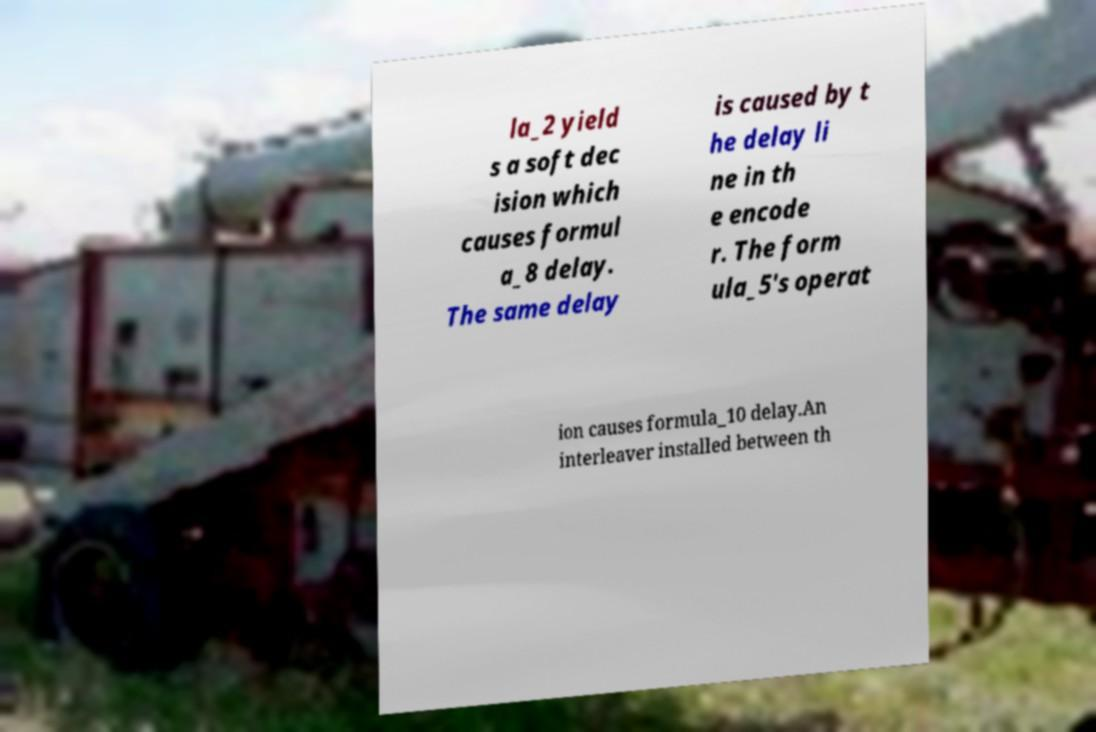Could you extract and type out the text from this image? la_2 yield s a soft dec ision which causes formul a_8 delay. The same delay is caused by t he delay li ne in th e encode r. The form ula_5's operat ion causes formula_10 delay.An interleaver installed between th 